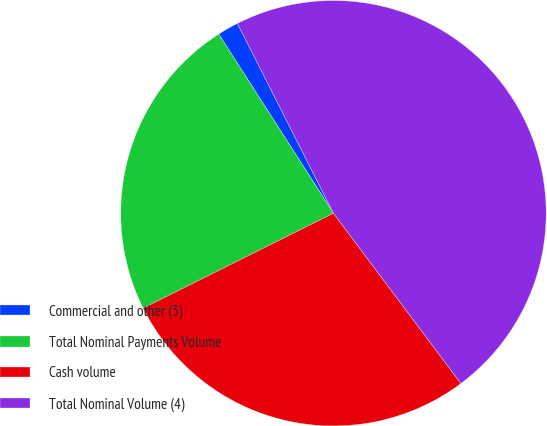Convert chart. <chart><loc_0><loc_0><loc_500><loc_500><pie_chart><fcel>Commercial and other (3)<fcel>Total Nominal Payments Volume<fcel>Cash volume<fcel>Total Nominal Volume (4)<nl><fcel>1.61%<fcel>23.3%<fcel>27.86%<fcel>47.23%<nl></chart> 